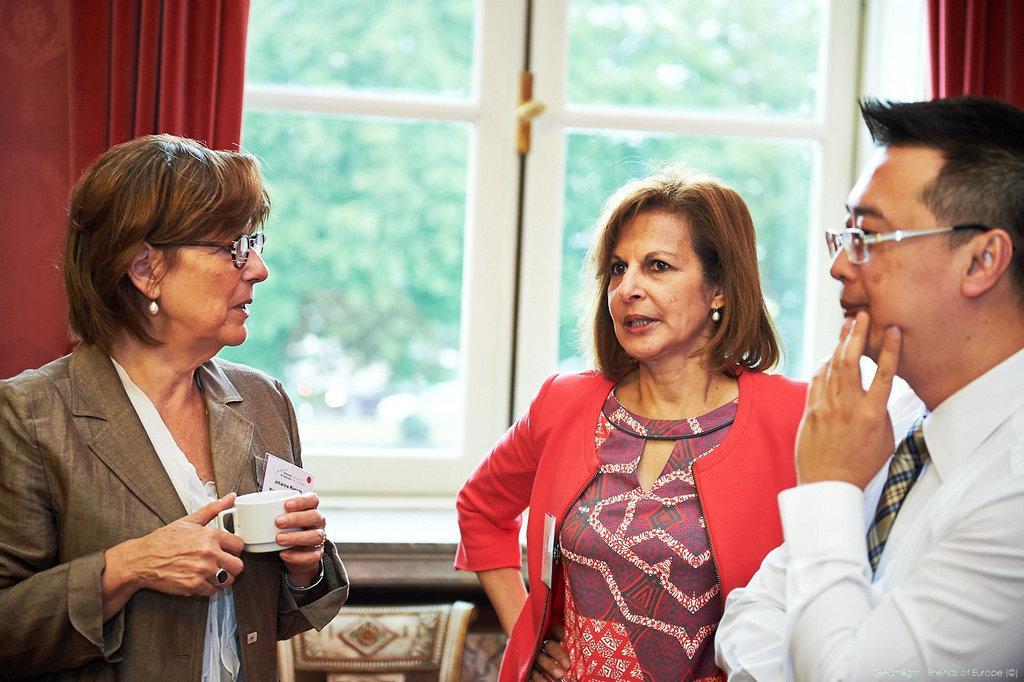Describe this image in one or two sentences. In this picture we can see three people and a woman wore spectacles and holding a cup with her hands and at the back of her we can see some objects and a window with curtains and in the background we can see trees and it is blurry. 